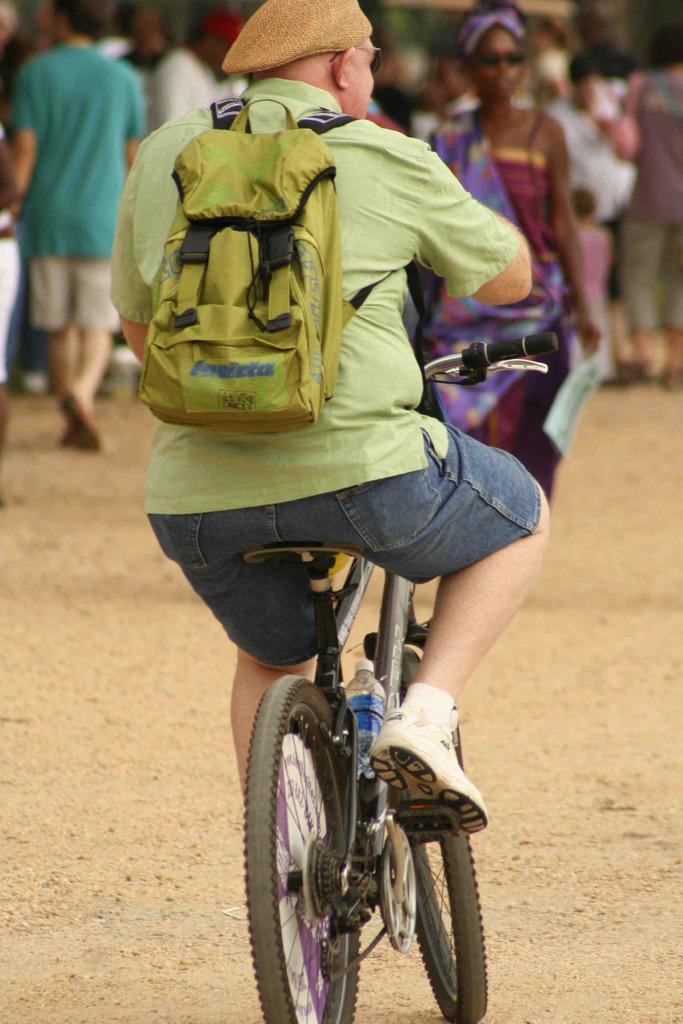Describe this image in one or two sentences. This person sitting and riding bicycle and wear bag and cap. In front of this person we can see few persons. 